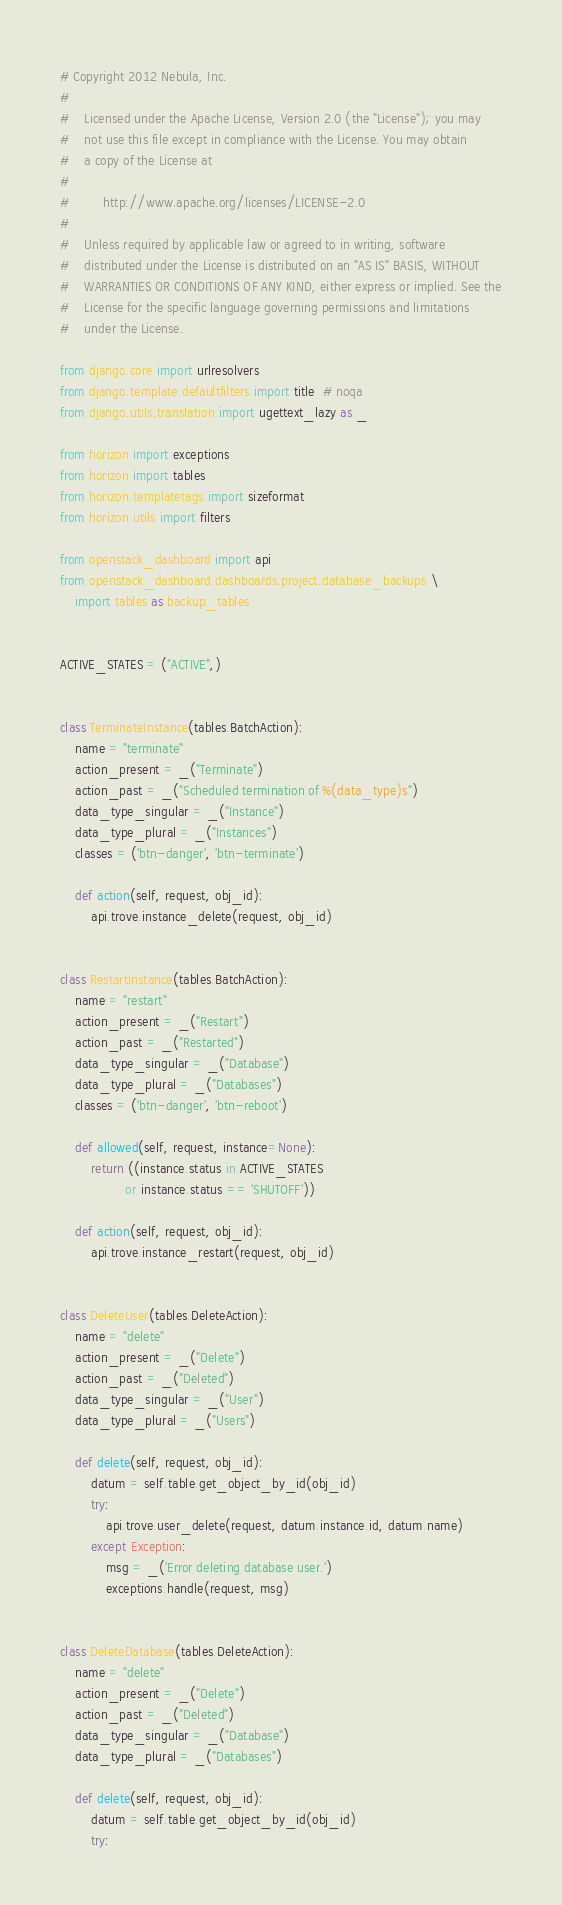Convert code to text. <code><loc_0><loc_0><loc_500><loc_500><_Python_># Copyright 2012 Nebula, Inc.
#
#    Licensed under the Apache License, Version 2.0 (the "License"); you may
#    not use this file except in compliance with the License. You may obtain
#    a copy of the License at
#
#         http://www.apache.org/licenses/LICENSE-2.0
#
#    Unless required by applicable law or agreed to in writing, software
#    distributed under the License is distributed on an "AS IS" BASIS, WITHOUT
#    WARRANTIES OR CONDITIONS OF ANY KIND, either express or implied. See the
#    License for the specific language governing permissions and limitations
#    under the License.

from django.core import urlresolvers
from django.template.defaultfilters import title  # noqa
from django.utils.translation import ugettext_lazy as _

from horizon import exceptions
from horizon import tables
from horizon.templatetags import sizeformat
from horizon.utils import filters

from openstack_dashboard import api
from openstack_dashboard.dashboards.project.database_backups \
    import tables as backup_tables


ACTIVE_STATES = ("ACTIVE",)


class TerminateInstance(tables.BatchAction):
    name = "terminate"
    action_present = _("Terminate")
    action_past = _("Scheduled termination of %(data_type)s")
    data_type_singular = _("Instance")
    data_type_plural = _("Instances")
    classes = ('btn-danger', 'btn-terminate')

    def action(self, request, obj_id):
        api.trove.instance_delete(request, obj_id)


class RestartInstance(tables.BatchAction):
    name = "restart"
    action_present = _("Restart")
    action_past = _("Restarted")
    data_type_singular = _("Database")
    data_type_plural = _("Databases")
    classes = ('btn-danger', 'btn-reboot')

    def allowed(self, request, instance=None):
        return ((instance.status in ACTIVE_STATES
                 or instance.status == 'SHUTOFF'))

    def action(self, request, obj_id):
        api.trove.instance_restart(request, obj_id)


class DeleteUser(tables.DeleteAction):
    name = "delete"
    action_present = _("Delete")
    action_past = _("Deleted")
    data_type_singular = _("User")
    data_type_plural = _("Users")

    def delete(self, request, obj_id):
        datum = self.table.get_object_by_id(obj_id)
        try:
            api.trove.user_delete(request, datum.instance.id, datum.name)
        except Exception:
            msg = _('Error deleting database user.')
            exceptions.handle(request, msg)


class DeleteDatabase(tables.DeleteAction):
    name = "delete"
    action_present = _("Delete")
    action_past = _("Deleted")
    data_type_singular = _("Database")
    data_type_plural = _("Databases")

    def delete(self, request, obj_id):
        datum = self.table.get_object_by_id(obj_id)
        try:</code> 